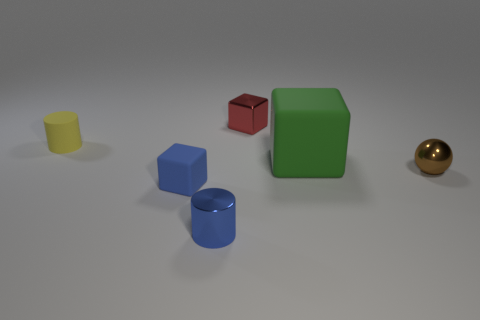Add 1 blue matte cubes. How many objects exist? 7 Subtract all cylinders. How many objects are left? 4 Subtract 0 cyan spheres. How many objects are left? 6 Subtract all metallic cylinders. Subtract all big blue things. How many objects are left? 5 Add 6 blue things. How many blue things are left? 8 Add 6 small cyan metal objects. How many small cyan metal objects exist? 6 